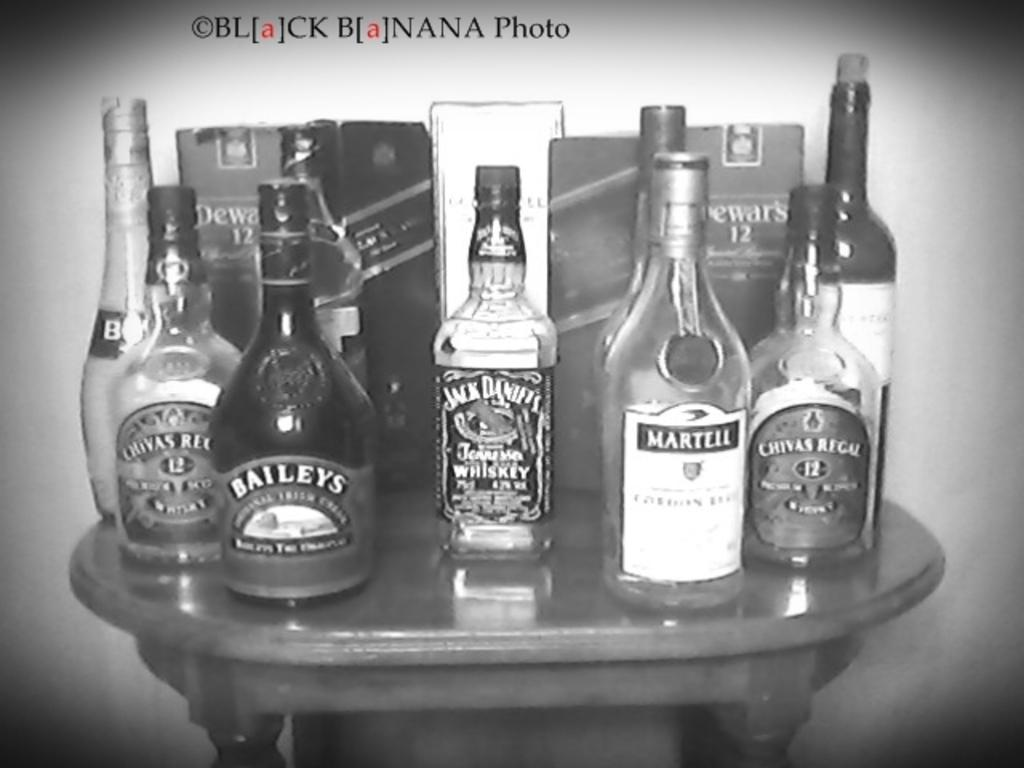Provide a one-sentence caption for the provided image. A bunch of bottles of liquor are on a table including Jack Daniel's Whiskey. 